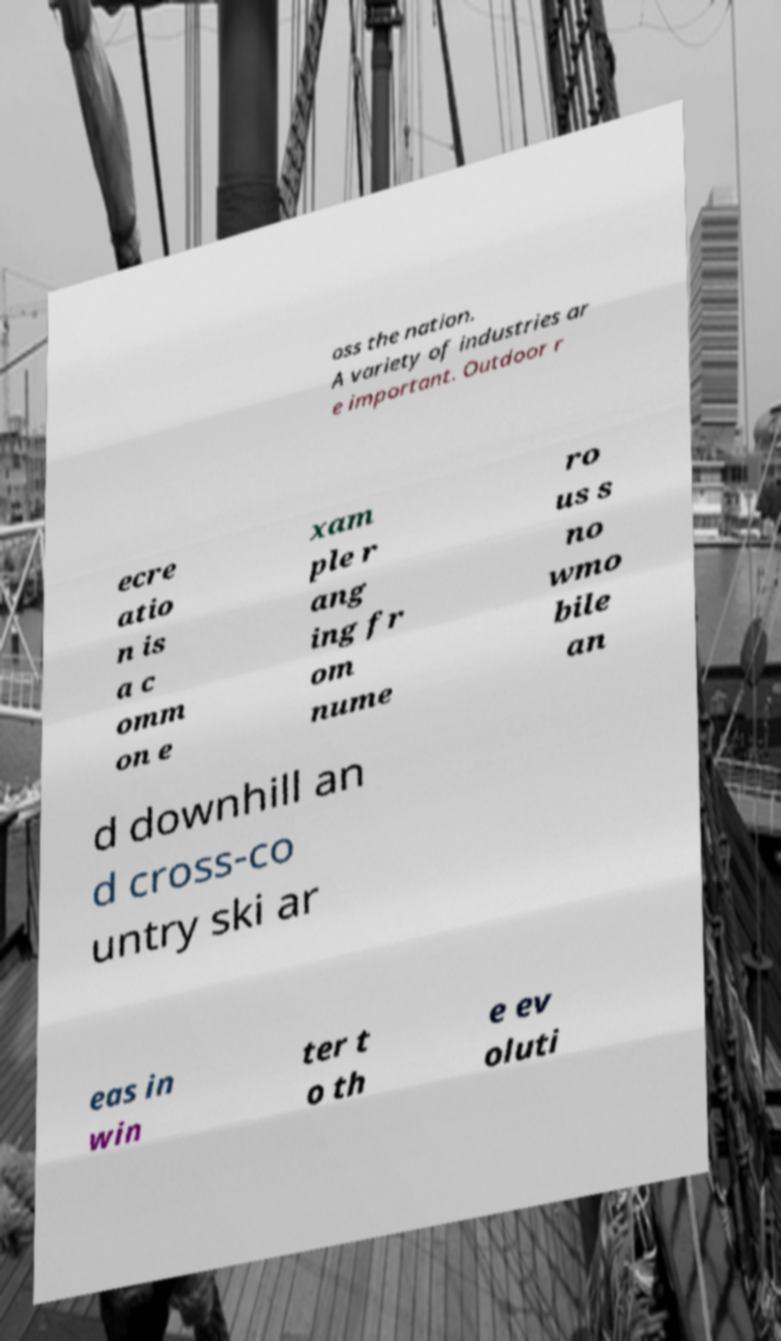What messages or text are displayed in this image? I need them in a readable, typed format. oss the nation. A variety of industries ar e important. Outdoor r ecre atio n is a c omm on e xam ple r ang ing fr om nume ro us s no wmo bile an d downhill an d cross-co untry ski ar eas in win ter t o th e ev oluti 